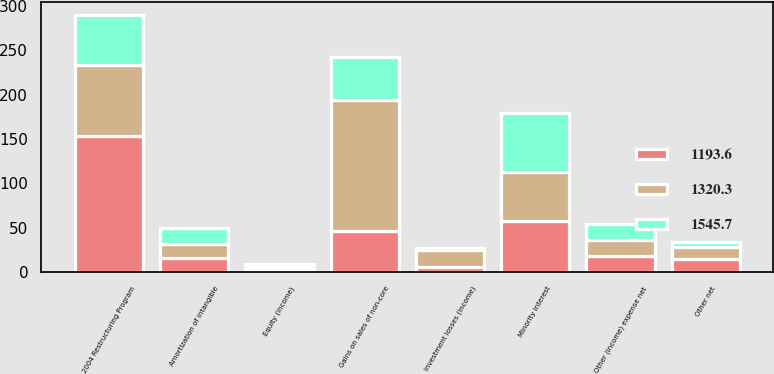<chart> <loc_0><loc_0><loc_500><loc_500><stacked_bar_chart><ecel><fcel>Other (income) expense net<fcel>Minority interest<fcel>Amortization of intangible<fcel>Equity (income)<fcel>Gains on sales of non-core<fcel>2004 Restructuring Program<fcel>Investment losses (income)<fcel>Other net<nl><fcel>1545.7<fcel>18.2<fcel>67.1<fcel>18.2<fcel>3.7<fcel>48.6<fcel>55.6<fcel>1.5<fcel>6.2<nl><fcel>1193.6<fcel>18.2<fcel>57.5<fcel>16.3<fcel>3.4<fcel>46.5<fcel>153.1<fcel>5.7<fcel>14.6<nl><fcel>1320.3<fcel>18.2<fcel>55.3<fcel>15.6<fcel>2<fcel>147.9<fcel>80.8<fcel>19.7<fcel>13.7<nl></chart> 